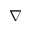<formula> <loc_0><loc_0><loc_500><loc_500>\nabla</formula> 